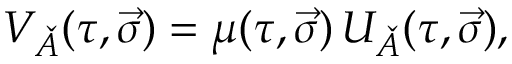<formula> <loc_0><loc_0><loc_500><loc_500>V _ { \check { A } } ( \tau , \vec { \sigma } ) = \mu ( \tau , \vec { \sigma } ) \, U _ { \check { A } } ( \tau , \vec { \sigma } ) ,</formula> 